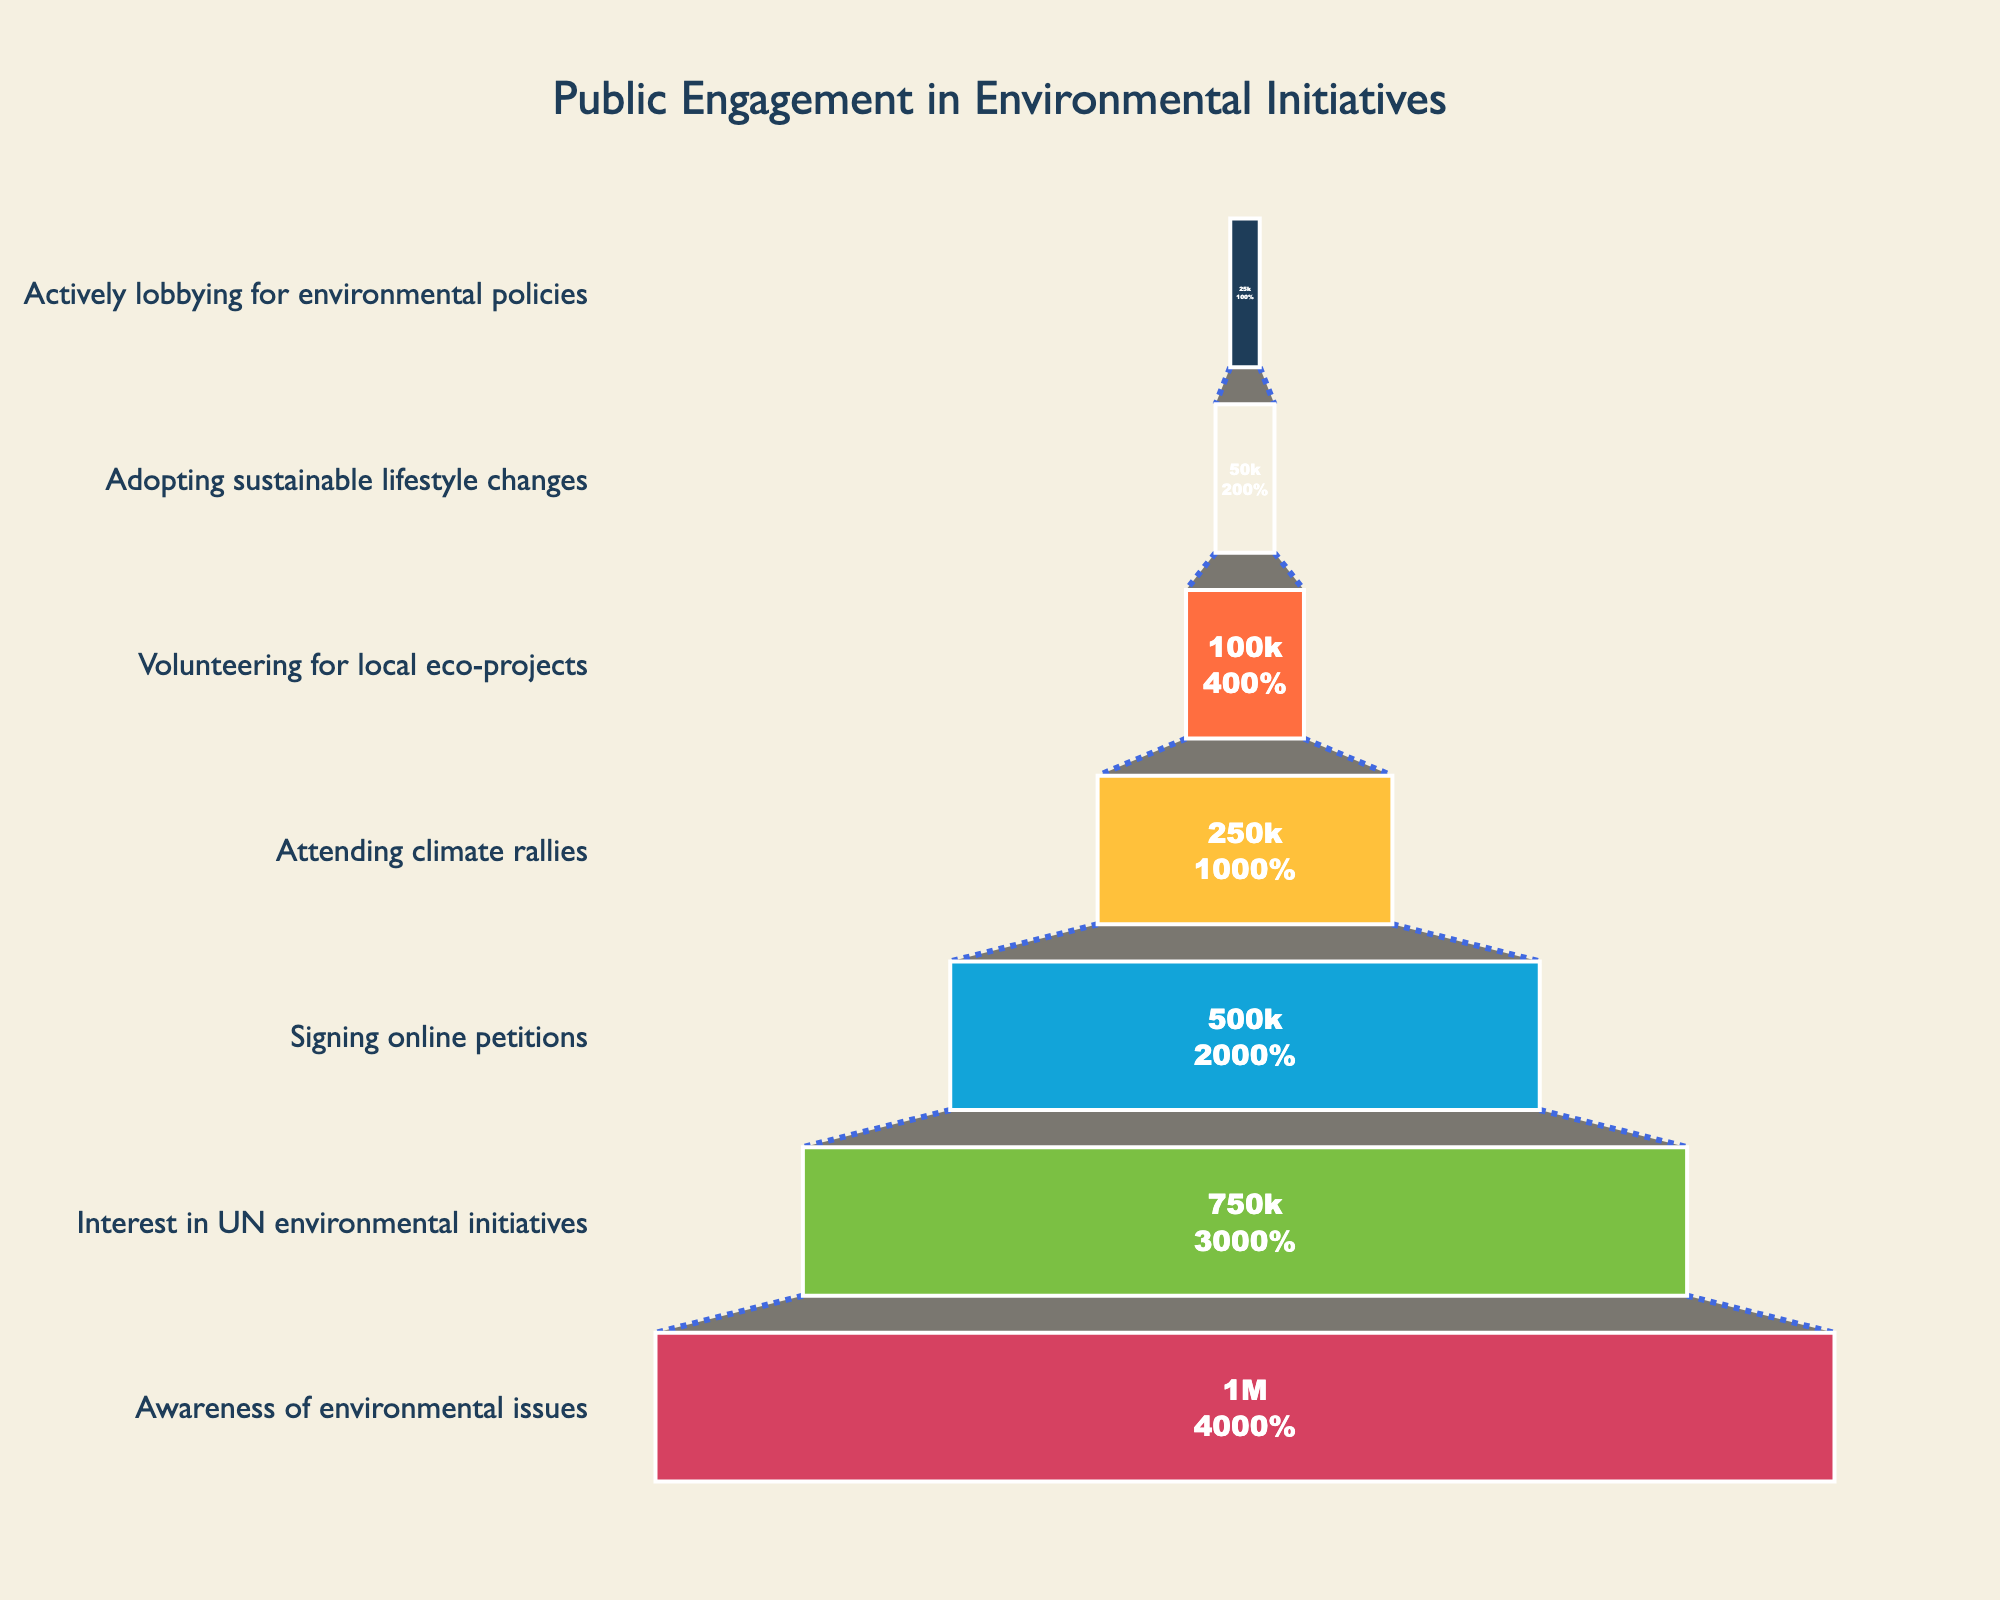Which stage has the highest number of participants? Observe the funnel chart and note the stage with the widest section representing the highest number of participants. This stage is "Awareness of environmental issues" with 1,000,000 participants.
Answer: Awareness of environmental issues Which stage has the lowest number of participants? Look for the narrowest section of the funnel chart to identify the stage with the fewest participants. This stage is "Actively lobbying for environmental policies" with 25,000 participants.
Answer: Actively lobbying for environmental policies How many people transitioned from "Signing online petitions" to "Attending climate rallies"? Subtract the number of participants in the "Attending climate rallies" stage from those in the "Signing online petitions" stage: 500,000 - 250,000 = 250,000 people.
Answer: 250,000 What proportion of participants showing interest in UN environmental initiatives went on to sign online petitions? Calculate the ratio of participants who signed online petitions to those interested in UN initiatives: 500,000 (Signing online petitions) / 750,000 (Interest in UN initiatives) = 0.67, then convert to a percentage.
Answer: 67% How does the number of participants in "Volunteering for local eco-projects" compare to those in "Adopting sustainable lifestyle changes"? Compare the participant numbers: Volunteering for local eco-projects has 100,000 and Adopting sustainable lifestyle changes has 50,000. 100,000 is twice as much as 50,000.
Answer: Twice as many What percentage of participants who are aware of environmental issues actually adopt sustainable lifestyle changes? Calculate the percentage: 50,000 (Adopting sustainable lifestyle changes) / 1,000,000 (Awareness of environmental issues) = 0.05, then convert to a percentage.
Answer: 5% Identify the stages where participant numbers drop by half or more. Compare each stage with the next: from "Awareness of environmental issues" to "Interest in UN environmental initiatives" (1000000 to 750000 is less than half), "Signing online petitions" to "Attending climate rallies" (500000 to 250000 is exactly half), and "Volunteering for local eco-projects" to "Adopting sustainable lifestyle changes" (100000 to 50000 is exactly half).
Answer: Signing online petitions to Attending climate rallies, Volunteering for local eco-projects to Adopting sustainable lifestyle changes 